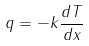<formula> <loc_0><loc_0><loc_500><loc_500>q = - k \frac { d T } { d x }</formula> 